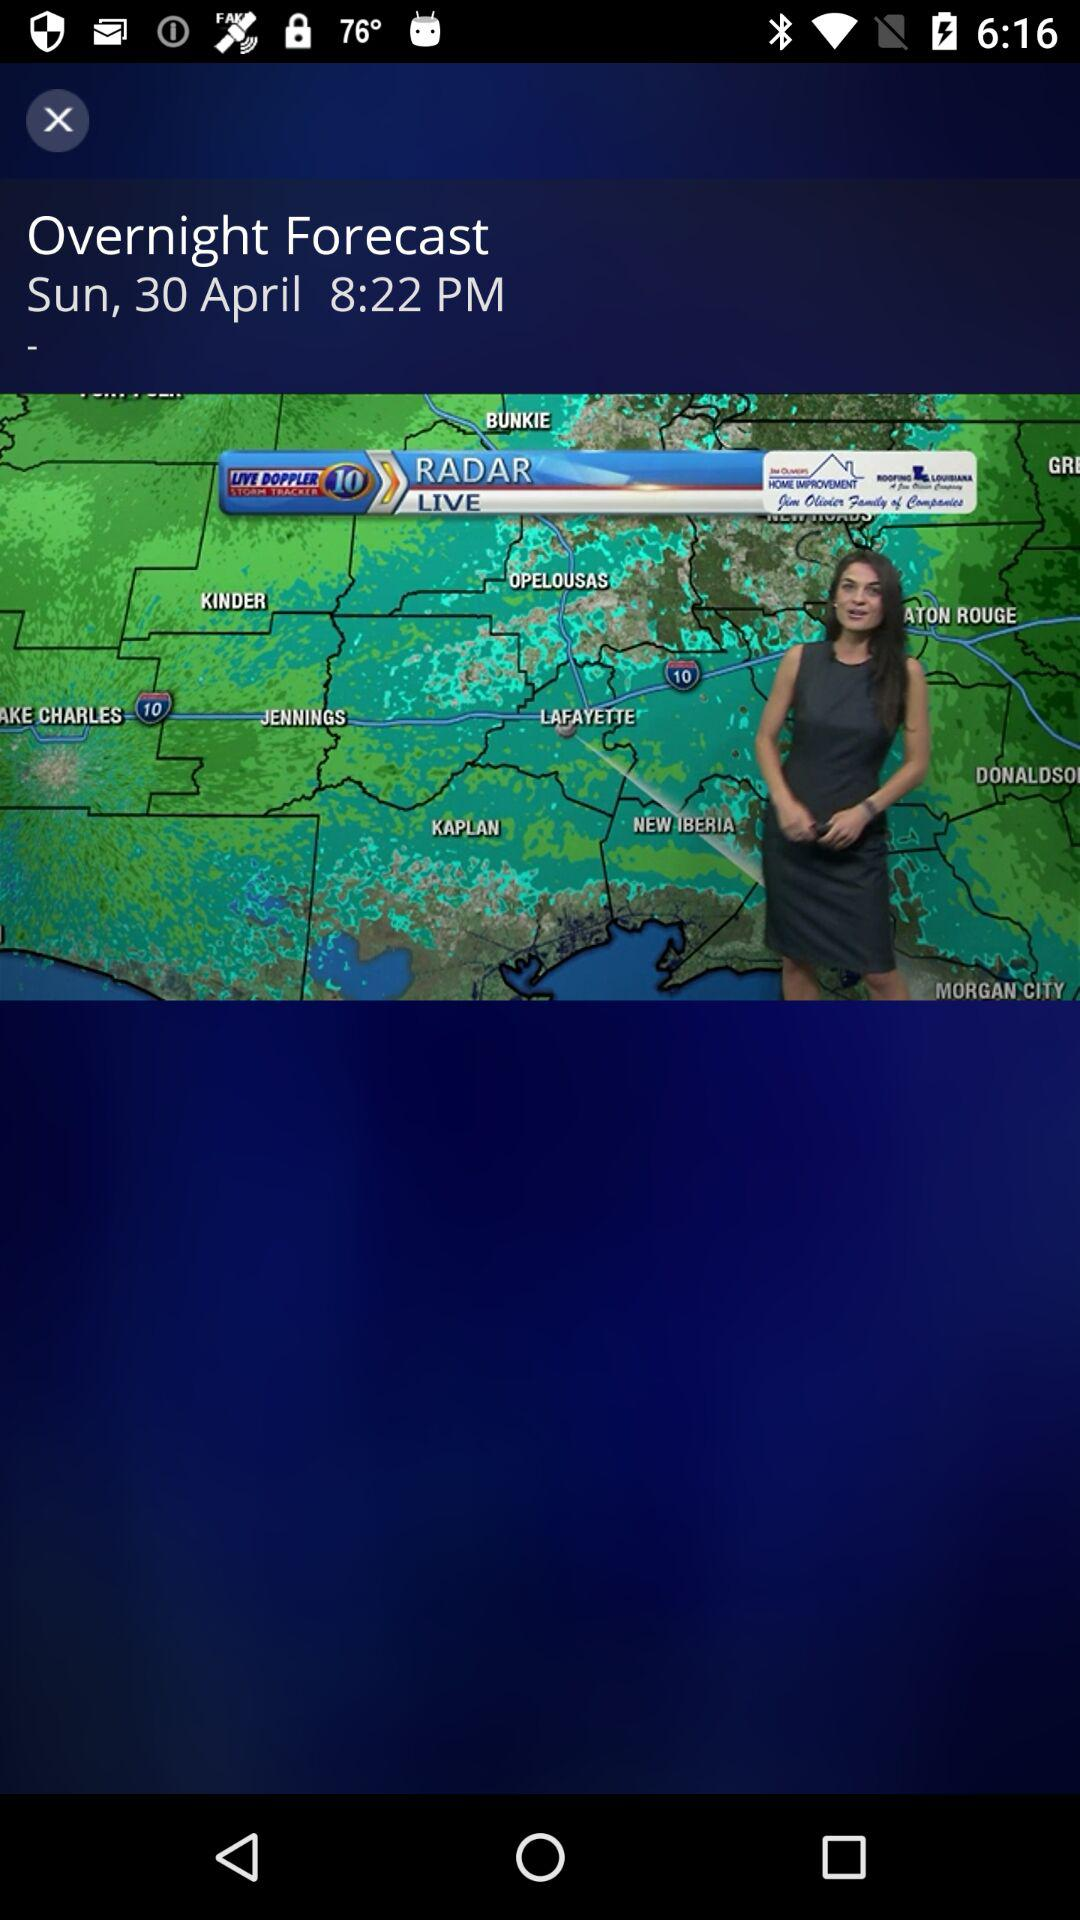When was the overnight forecast declared? The overnight forecast was declared on Sunday, April 30 at 8:22 PM. 